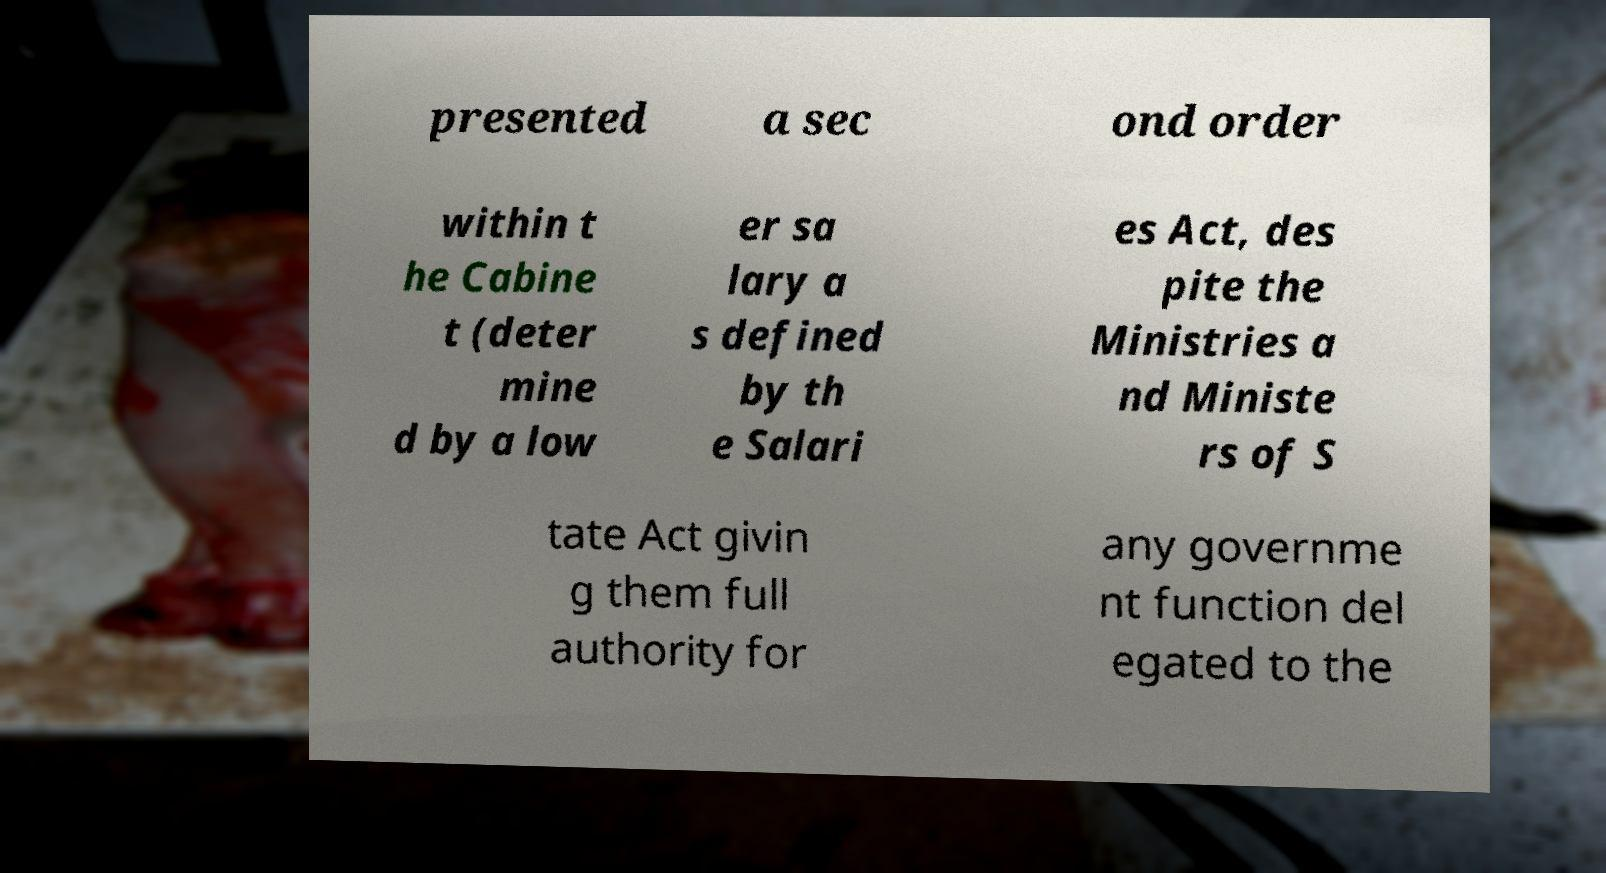What messages or text are displayed in this image? I need them in a readable, typed format. presented a sec ond order within t he Cabine t (deter mine d by a low er sa lary a s defined by th e Salari es Act, des pite the Ministries a nd Ministe rs of S tate Act givin g them full authority for any governme nt function del egated to the 